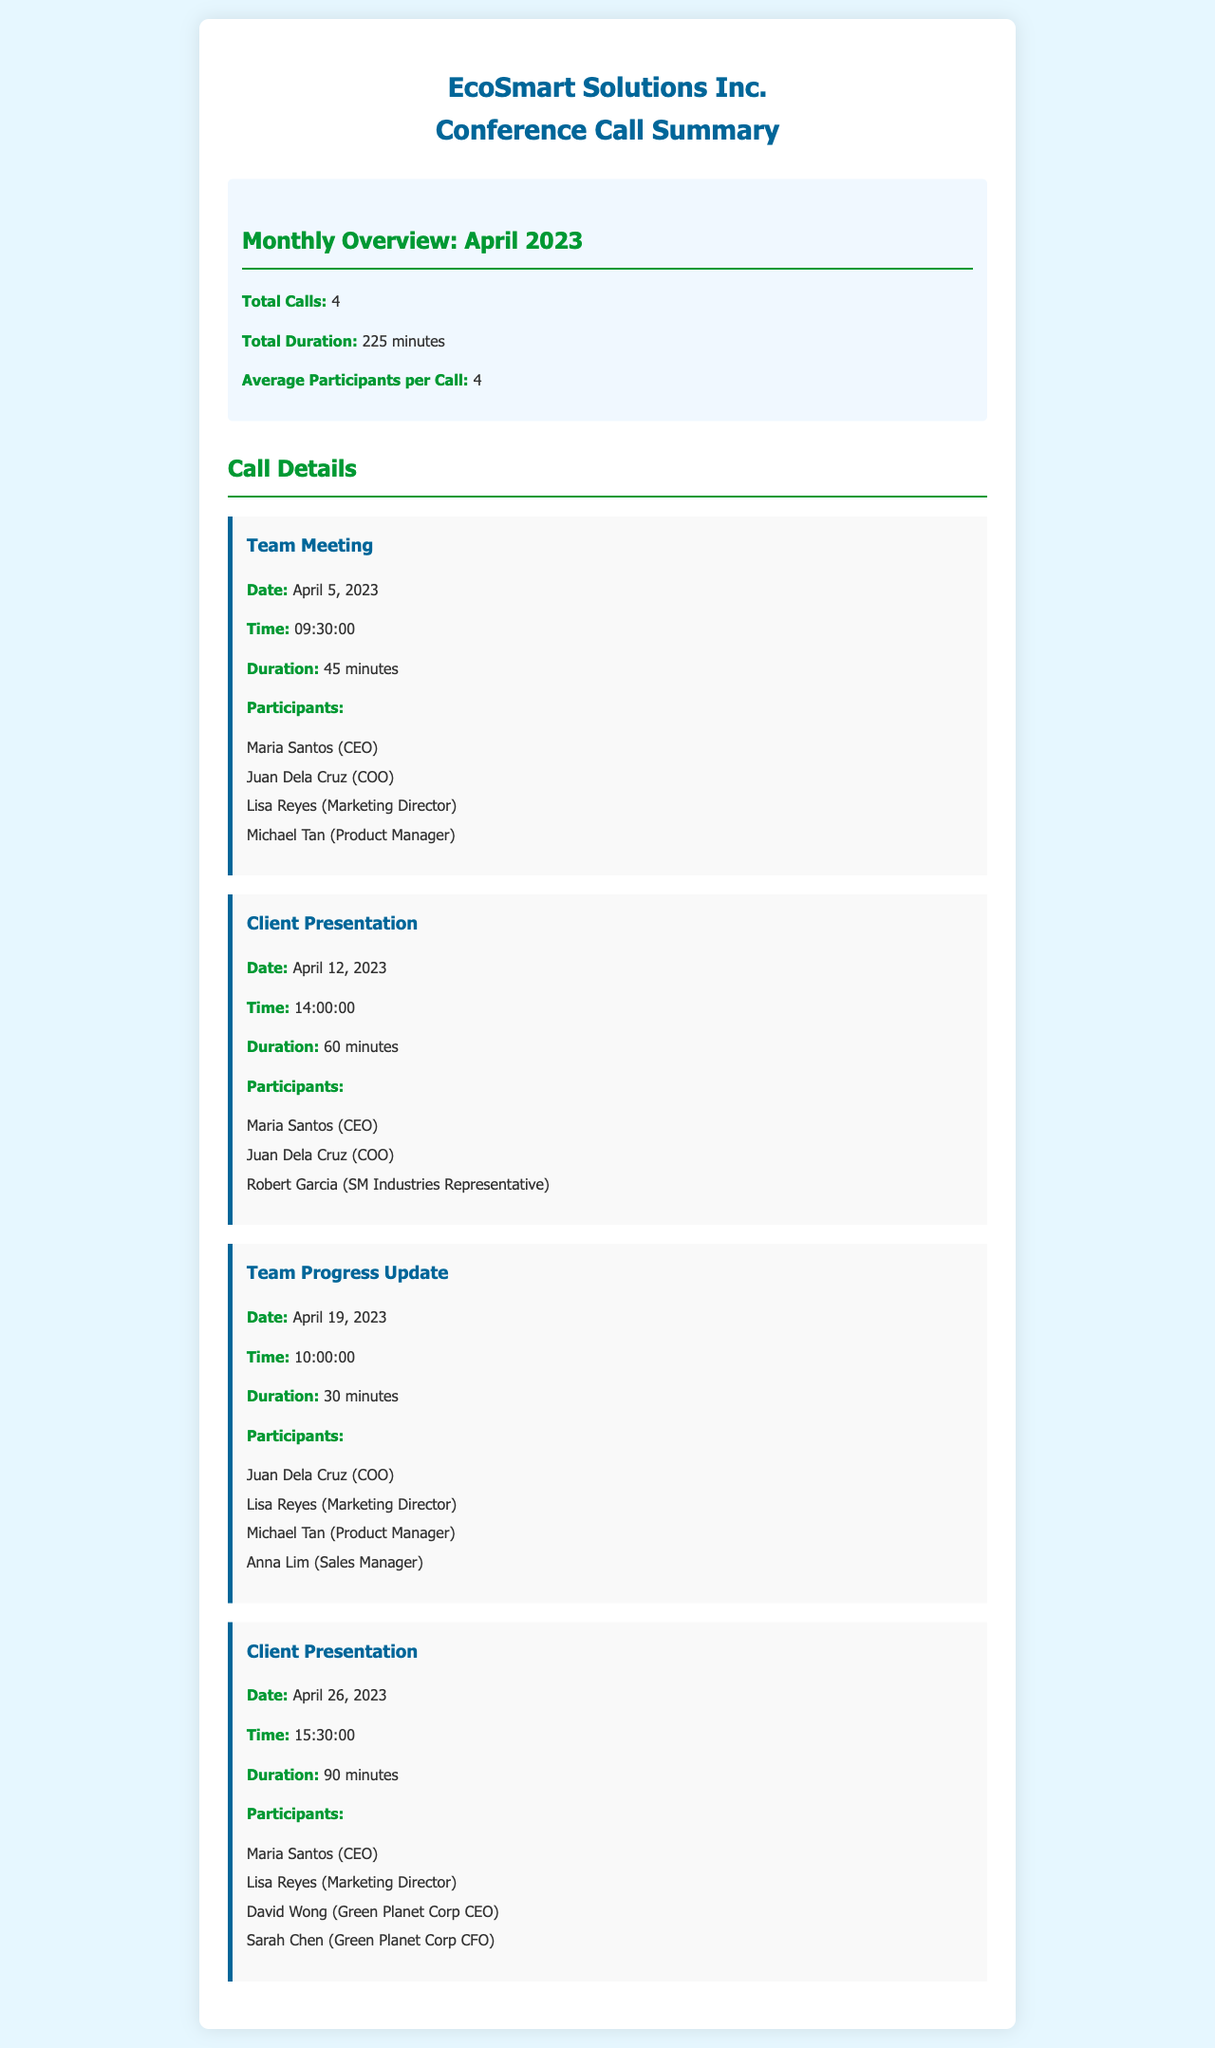what is the total number of conference calls? The document states that there were a total of 4 calls for the month of April 2023.
Answer: 4 what was the average duration of the calls? To find the average duration, we divide the total duration (225 minutes) by the total calls (4), which gives us 56.25 minutes.
Answer: 56.25 minutes who participated in the team meeting on April 5, 2023? The participants were Maria Santos, Juan Dela Cruz, Lisa Reyes, and Michael Tan.
Answer: Maria Santos, Juan Dela Cruz, Lisa Reyes, Michael Tan what was the duration of the client presentation on April 12, 2023? The document specifies that the client presentation lasted for 60 minutes.
Answer: 60 minutes how many participants were present during the team progress update? The team progress update had 4 participants according to the document.
Answer: 4 which participant attended both client presentations in April? Maria Santos attended both client presentations on April 12 and April 26, 2023.
Answer: Maria Santos what is the total duration of client presentations? The total duration of the client presentations is the sum of both presentations: 60 minutes + 90 minutes = 150 minutes.
Answer: 150 minutes when was the team progress update held? The document states it was held on April 19, 2023.
Answer: April 19, 2023 who were the participants in the client presentation on April 26, 2023? The participants were Maria Santos, Lisa Reyes, David Wong, and Sarah Chen.
Answer: Maria Santos, Lisa Reyes, David Wong, Sarah Chen 